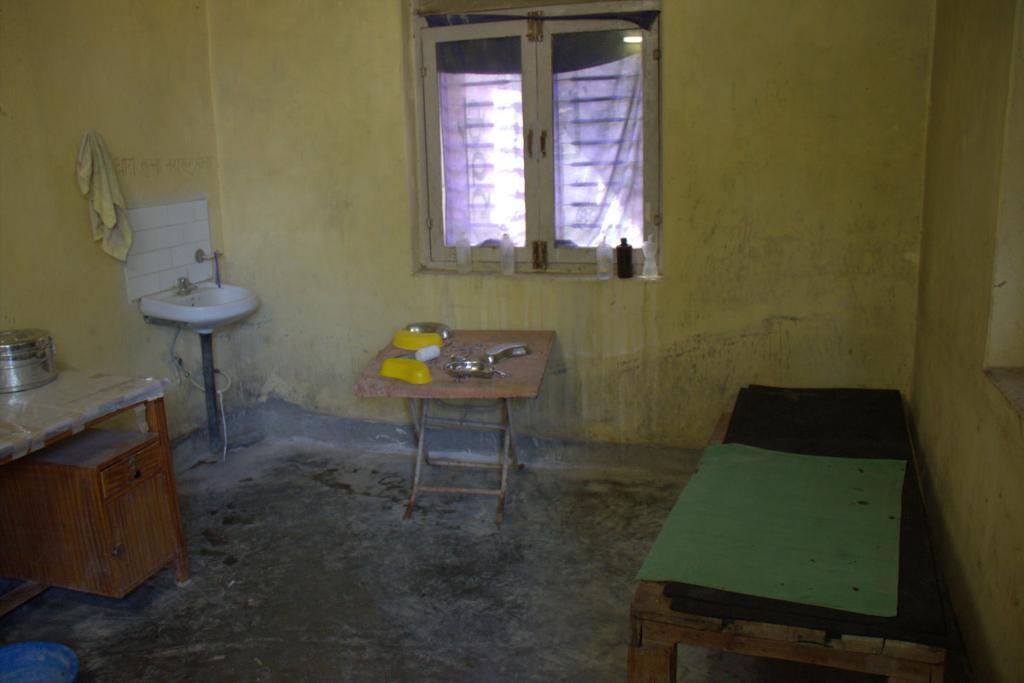Please provide a concise description of this image. It is a picture inside a house there is a bed table to the left there is a sink,behind it there is a yellow color wall, to the left of the sink there is a table and vessel on the table, to the right side to the wall there is a window. 